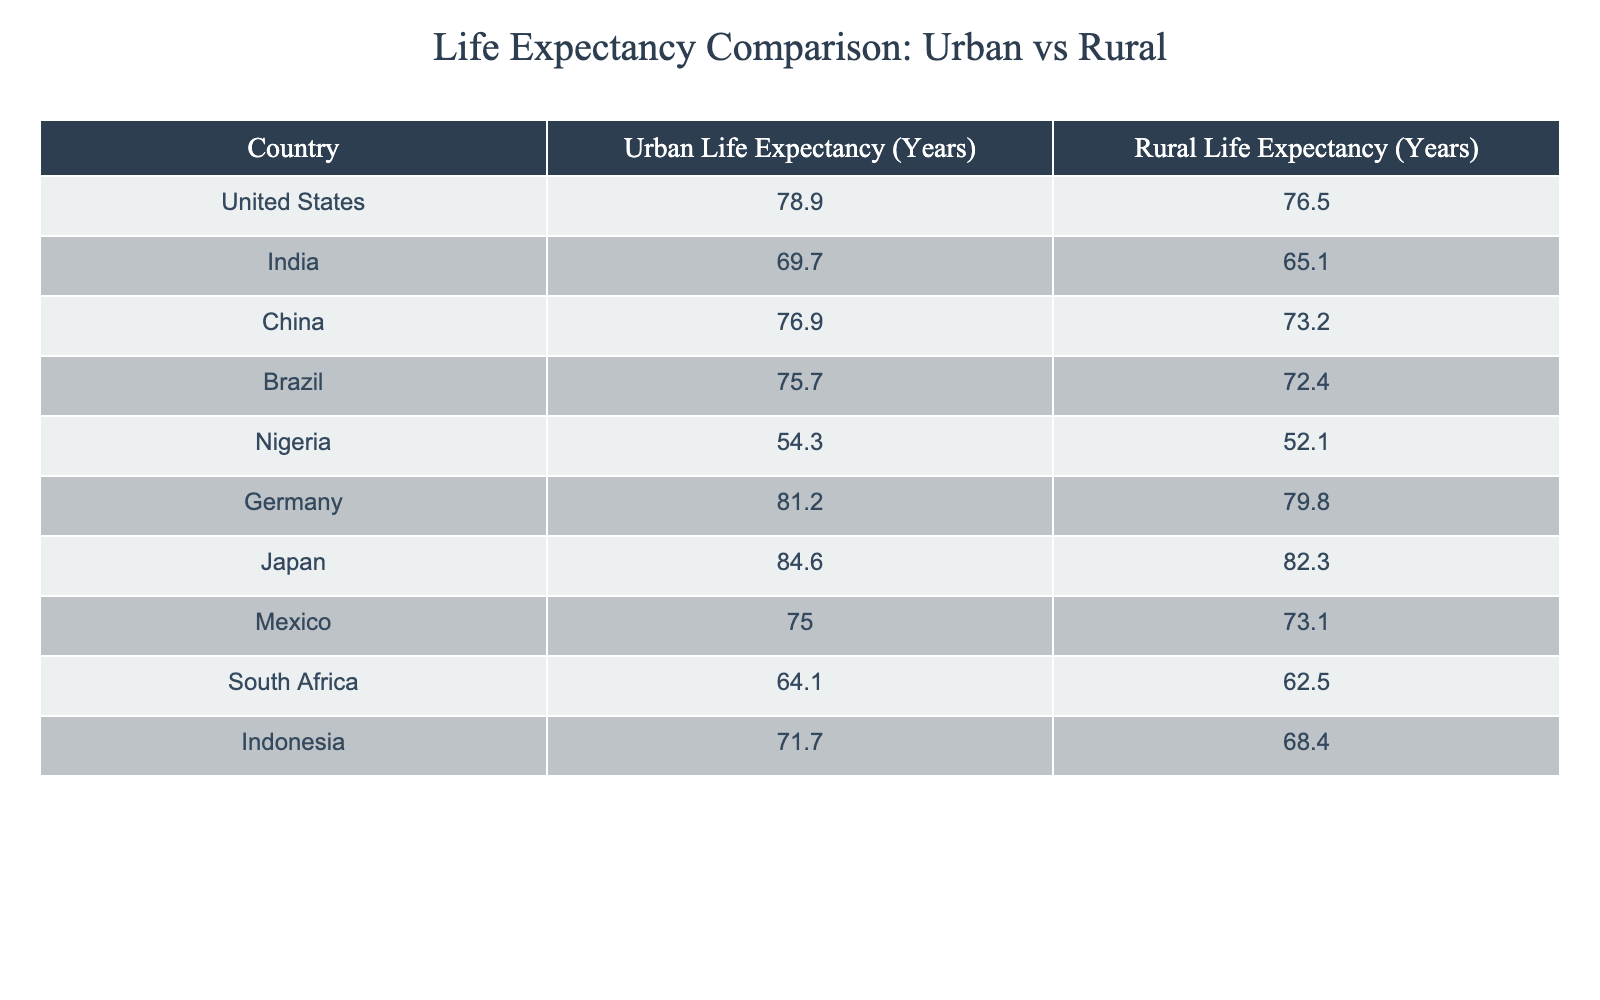What is the urban life expectancy in Germany? The urban life expectancy for Germany is explicitly listed in the table under the "Urban Life Expectancy" column.
Answer: 81.2 Which country has the highest rural life expectancy? By comparing the rural life expectancy values from all countries, Japan has the highest figure at 82.3 years.
Answer: Japan What is the difference in life expectancy between urban and rural populations in Brazil? The urban life expectancy in Brazil is 75.7 years, and the rural life expectancy is 72.4 years. The difference is calculated as 75.7 - 72.4 = 3.3 years.
Answer: 3.3 Is the urban life expectancy in Nigeria higher than that in South Africa? In the table, Nigeria's urban life expectancy is 54.3 while South Africa's is 64.1. Since 54.3 is less than 64.1, the statement is false.
Answer: No What is the average urban life expectancy of the countries listed? To compute the average, sum up all the urban life expectancy values: (78.9 + 69.7 + 76.9 + 75.7 + 54.3 + 81.2 + 84.6 + 75.0 + 64.1 + 71.7) =  81.0, then divide by the number of countries (10):  810.1 / 10 = 81.0 years.
Answer: 76.3 Which country has the lowest urban life expectancy? Reviewing the urban life expectancy values in the table, Nigeria has the lowest urban life expectancy at 54.3 years.
Answer: Nigeria Is the average rural life expectancy greater than 70 years? The total rural life expectancy values are (76.5 + 65.1 + 73.2 + 72.4 + 52.1 + 79.8 + 82.3 + 73.1 + 62.5 + 68.4) =  69.9 and dividing by 10 gives 69.9 which is less than 70, making the statement false.
Answer: No What is the sum of urban life expectancy for China and India? The urban life expectancy for China is 76.9 years and for India, it is 69.7 years. Adding these together: 76.9 + 69.7 = 146.6 years.
Answer: 146.6 In which country is the difference between urban and rural life expectancy the smallest? By reviewing the differences between urban and rural life expectancy for each country, we find that the smallest difference is in Germany, where it is 1.4 years (81.2 - 79.8).
Answer: Germany 